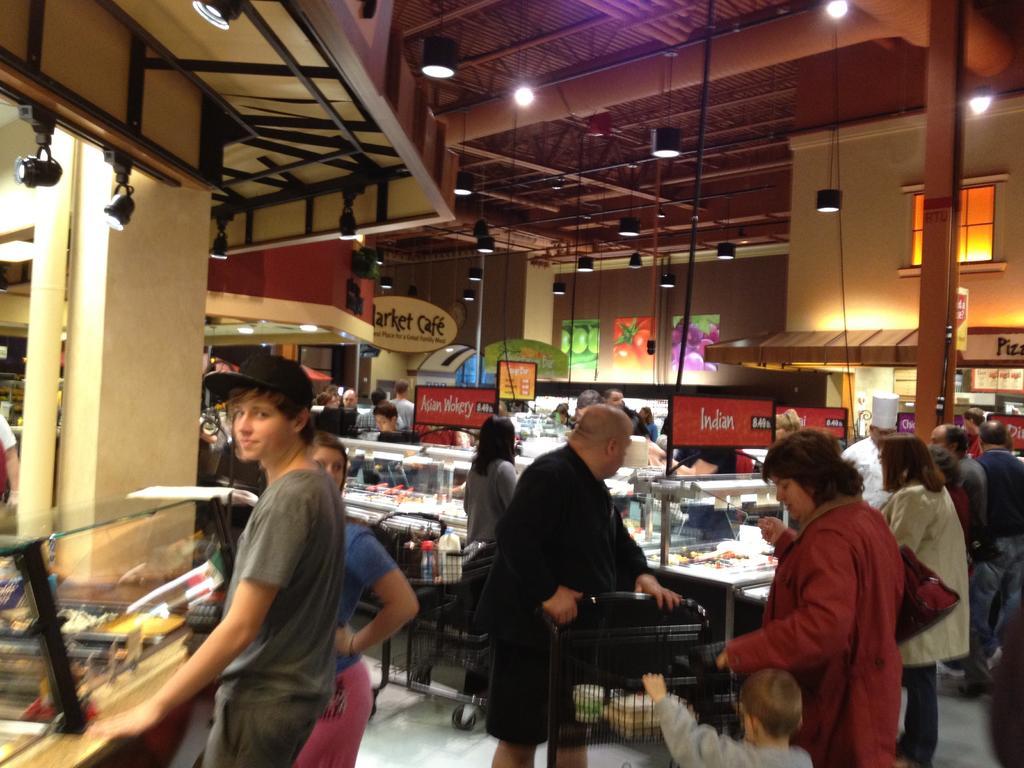How would you summarize this image in a sentence or two? In this image there are group of people standing, trolleys with some objects in it , stalls, lights, iron rods, papers stick to the wall,boards, items in the glass boxes. 